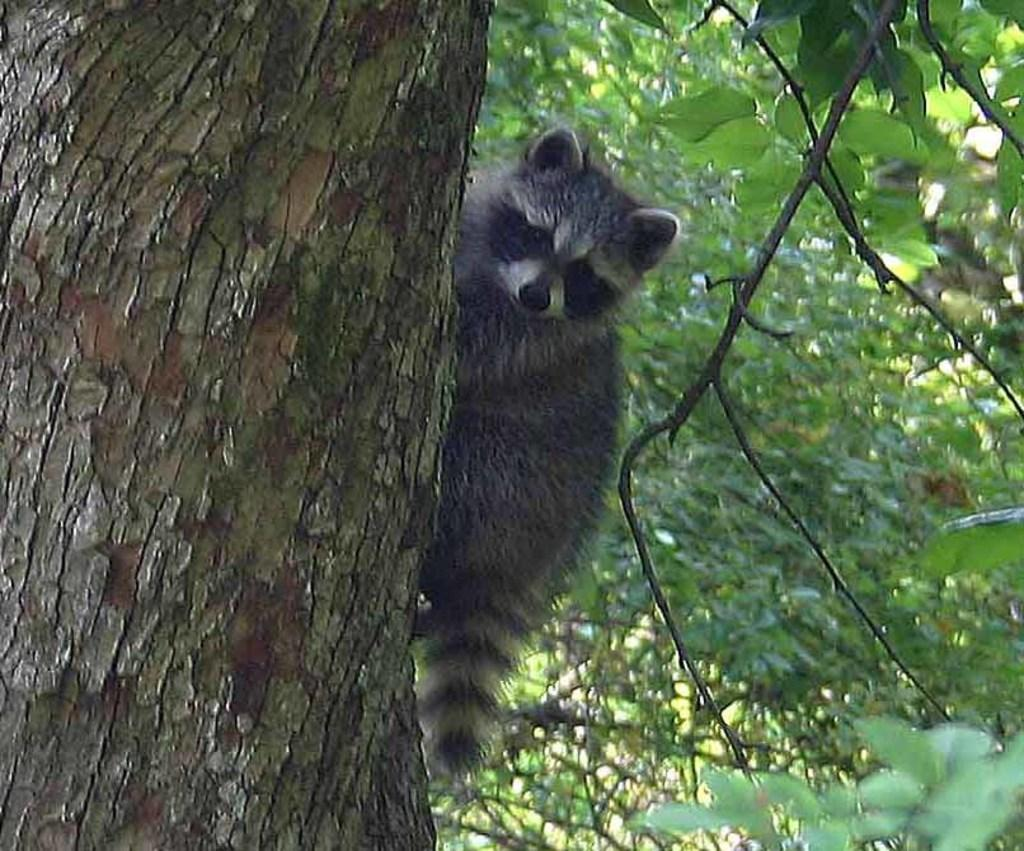What is the main subject in the center of the image? There is an animal in the center of the image. What color is the animal? The animal is black in color. What can be seen in the background of the image? There are trees in the background of the image. What type of ink is being used to write on the animal in the image? There is no ink or writing present on the animal in the image. 